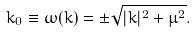Convert formula to latex. <formula><loc_0><loc_0><loc_500><loc_500>k _ { 0 } \equiv \omega ( { k } ) = \pm \sqrt { | { k } | ^ { 2 } + \mu ^ { 2 } } .</formula> 